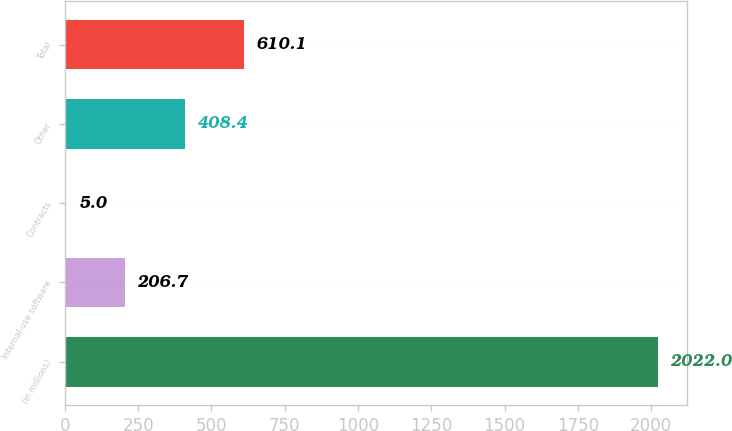<chart> <loc_0><loc_0><loc_500><loc_500><bar_chart><fcel>(in millions)<fcel>Internal-use software<fcel>Contracts<fcel>Other<fcel>Total<nl><fcel>2022<fcel>206.7<fcel>5<fcel>408.4<fcel>610.1<nl></chart> 